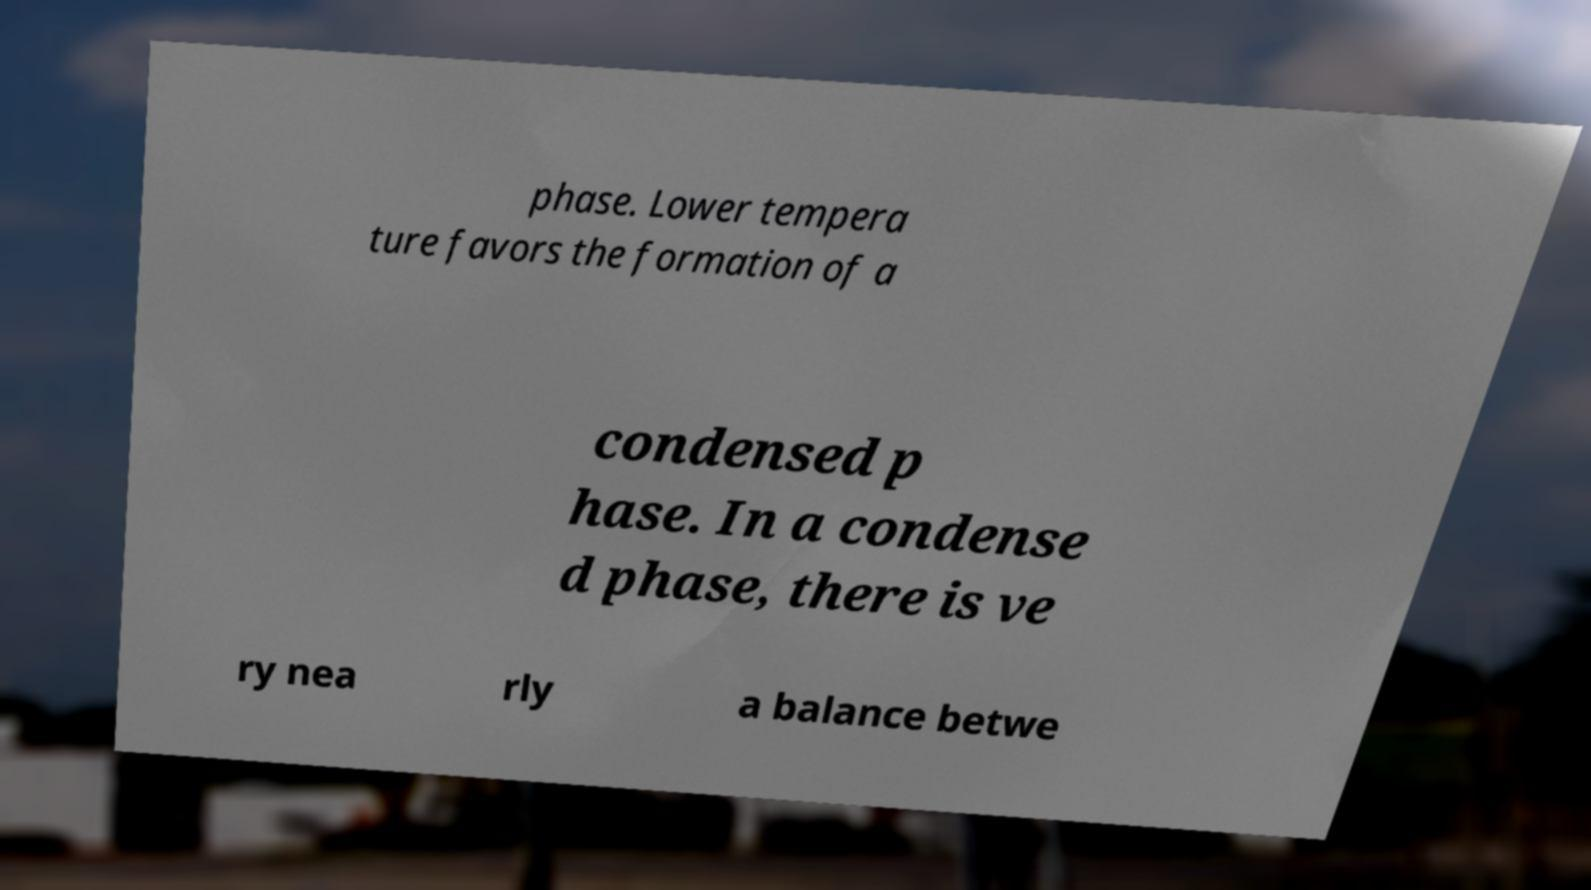Can you read and provide the text displayed in the image?This photo seems to have some interesting text. Can you extract and type it out for me? phase. Lower tempera ture favors the formation of a condensed p hase. In a condense d phase, there is ve ry nea rly a balance betwe 